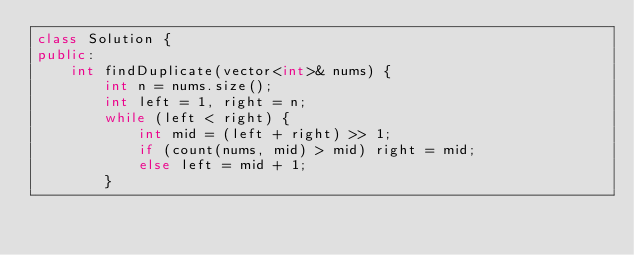<code> <loc_0><loc_0><loc_500><loc_500><_C++_>class Solution {
public:
    int findDuplicate(vector<int>& nums) {
        int n = nums.size();
        int left = 1, right = n;
        while (left < right) {
            int mid = (left + right) >> 1;
            if (count(nums, mid) > mid) right = mid;
            else left = mid + 1;
        }</code> 